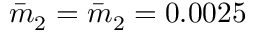<formula> <loc_0><loc_0><loc_500><loc_500>\bar { m } _ { 2 } = \bar { m } _ { 2 } = 0 . 0 0 2 5</formula> 